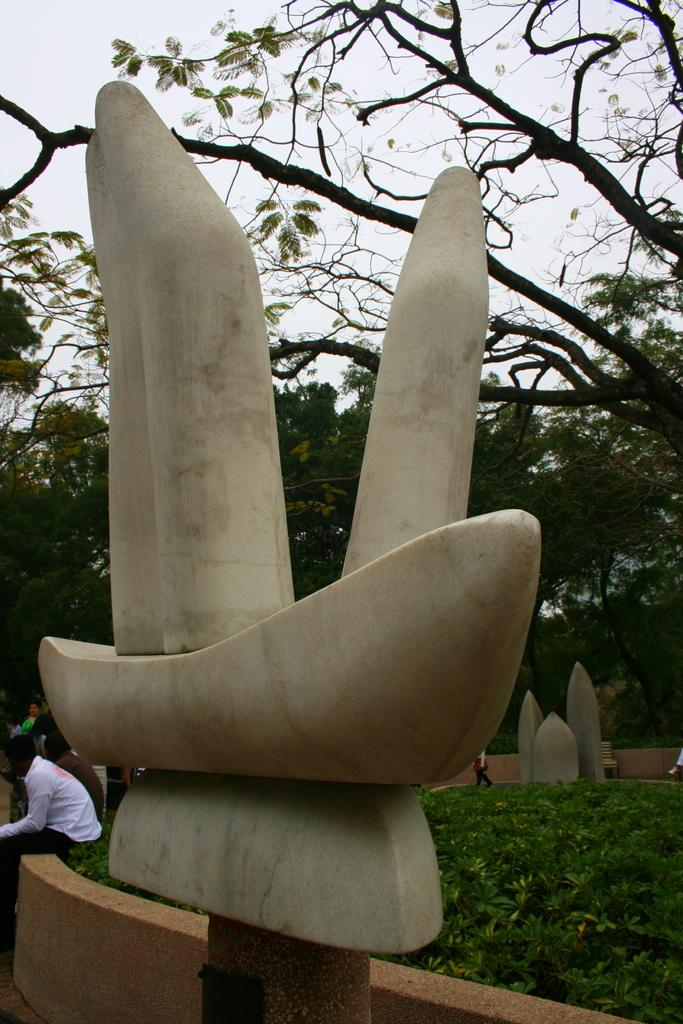What is the main subject of the image? There is a sculpture in the image. What is located at the bottom of the image? There are plants at the bottom of the image. What can be seen in the background of the image? There are trees in the background of the image. Are there any people visible in the image? Yes, there are people visible in the image. How does the beginner sculptor start working on the sculpture in the image? There is no information about the sculptor or their skill level in the image, so we cannot determine how they started working on the sculpture. 